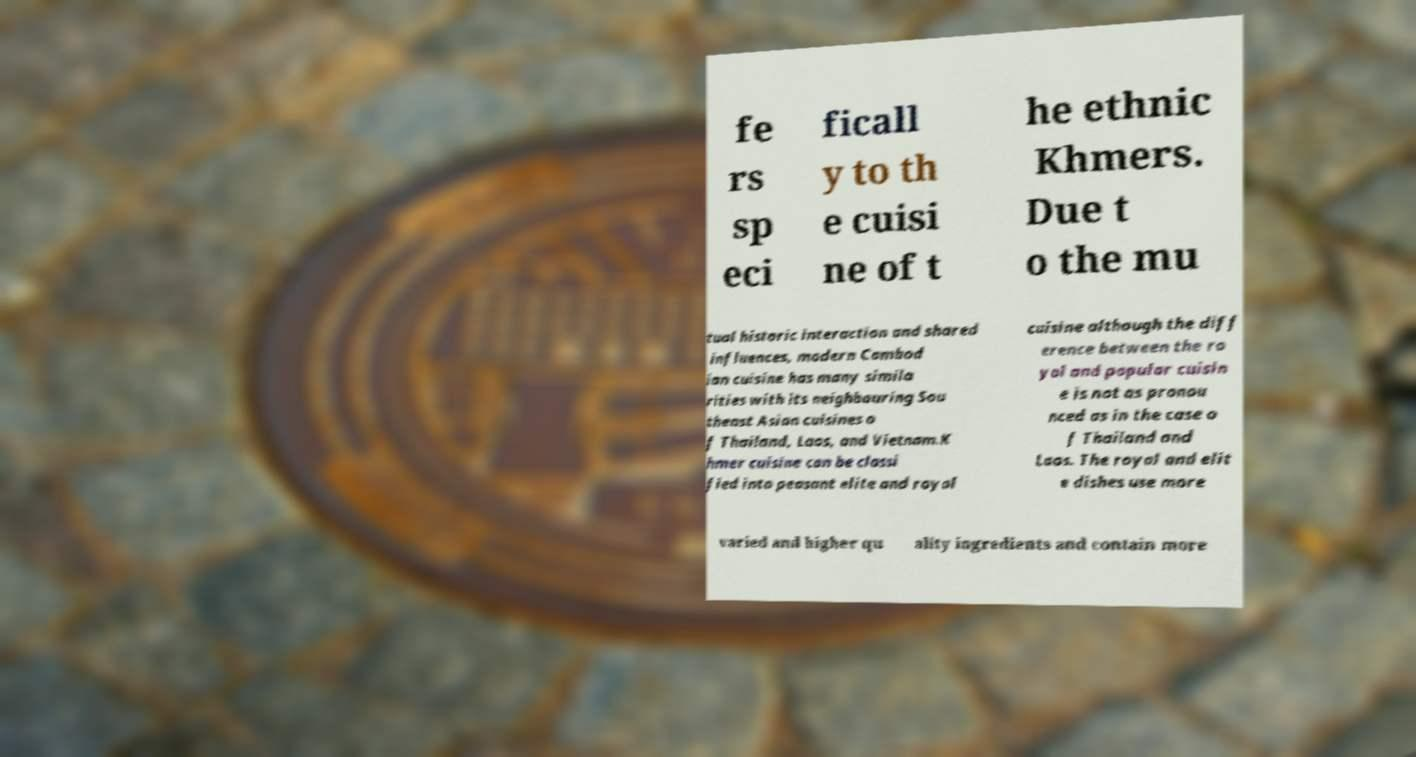Please identify and transcribe the text found in this image. fe rs sp eci ficall y to th e cuisi ne of t he ethnic Khmers. Due t o the mu tual historic interaction and shared influences, modern Cambod ian cuisine has many simila rities with its neighbouring Sou theast Asian cuisines o f Thailand, Laos, and Vietnam.K hmer cuisine can be classi fied into peasant elite and royal cuisine although the diff erence between the ro yal and popular cuisin e is not as pronou nced as in the case o f Thailand and Laos. The royal and elit e dishes use more varied and higher qu ality ingredients and contain more 